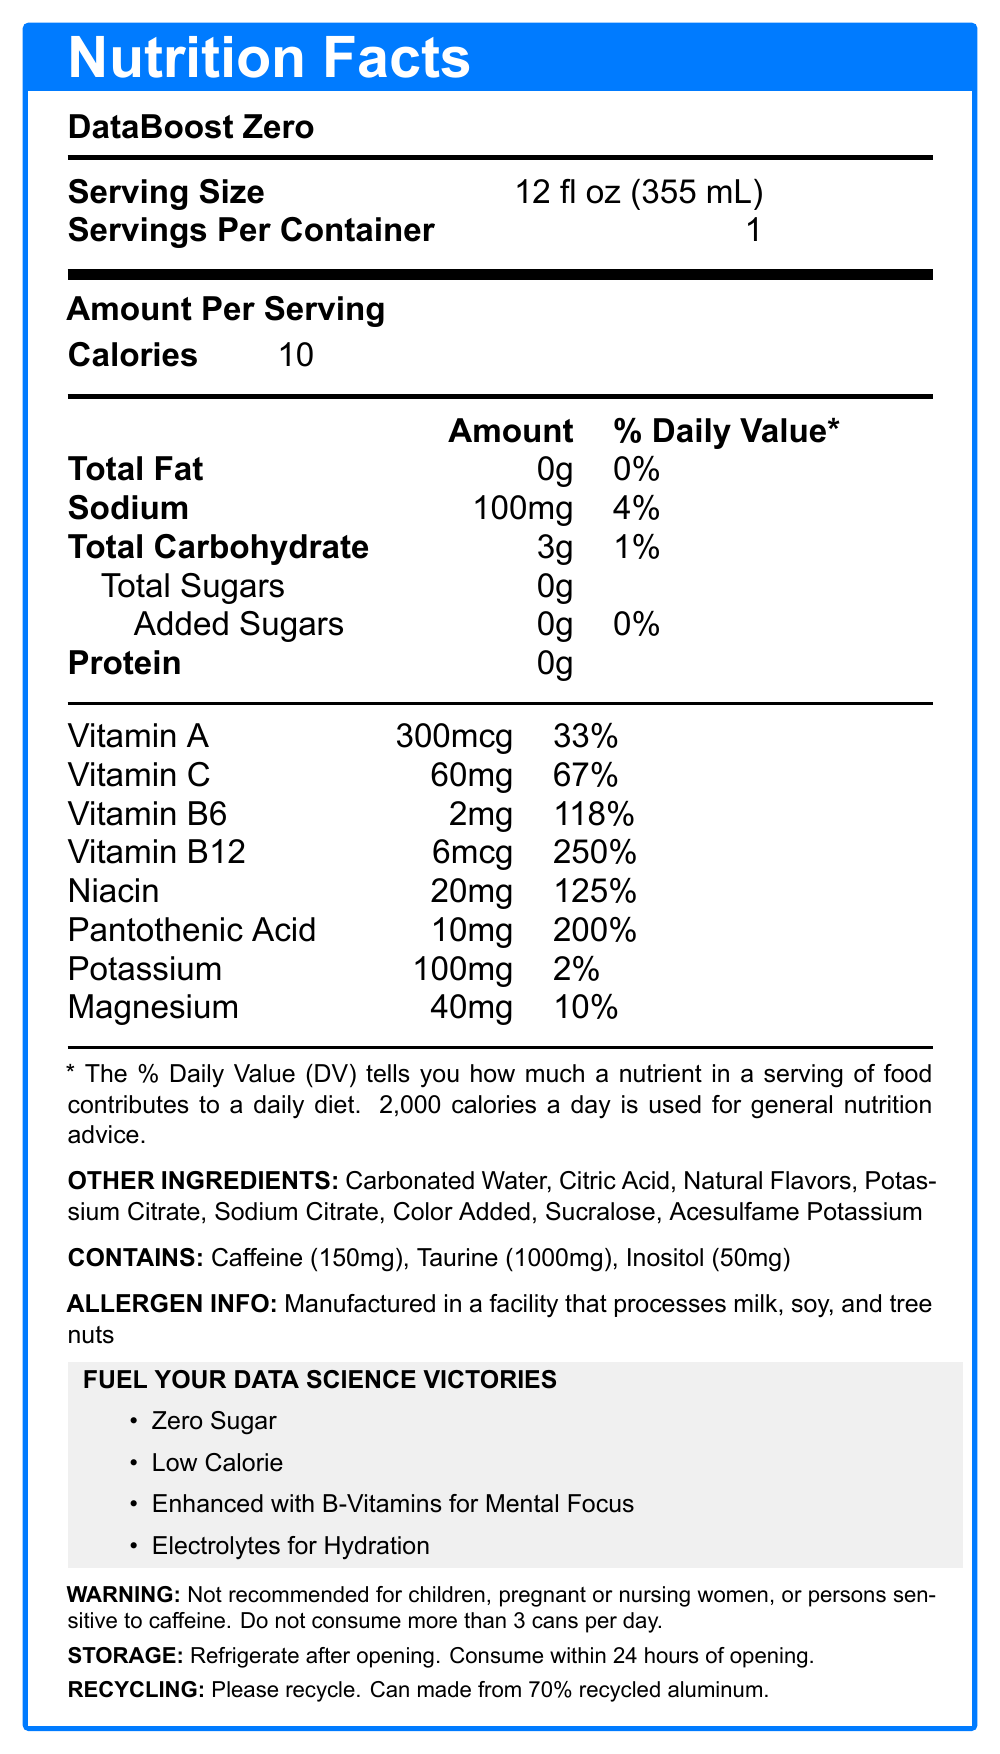what is the serving size of DataBoost Zero? The document specifies the serving size as 12 fl oz (355 mL) under the section "Serving Size".
Answer: 12 fl oz (355 mL) how many calories are there per serving? The document states that the amount per serving is 10 calories.
Answer: 10 calories what percentage of the daily value of sodium does one serving contain? The document lists 100mg of sodium per serving, which is 4% of the daily value.
Answer: 4% what vitamins are included in DataBoost Zero? The document lists these vitamins along with their amounts and daily values.
Answer: Vitamin A, Vitamin C, Vitamin B6, Vitamin B12, Niacin, Pantothenic Acid what is the main marketing tagline for DataBoost Zero? The document highlights the tagline “Fuel Your Data Science Victories”.
Answer: Fuel Your Data Science Victories what is the total carbohydrate content in a single serving? The document shows that the total carbohydrate amount per serving is 3g.
Answer: 3g which of the following is an artificial sweetener found in DataBoost Zero? A. Aspartame B. Sucralose C. Saccharin The document lists Sucralose and Acesulfame Potassium as the artificial sweeteners in DataBoost Zero.
Answer: B. Sucralose what is the daily value percentage of Pantothenic Acid in DataBoost Zero? A. 125% B. 200% C. 250% D. 33% The document specifies that the daily value percentage of Pantothenic Acid is 200%.
Answer: B. 200% is DataBoost Zero recommended for children? The document includes a warning that it is not recommended for children, pregnant or nursing women, or persons sensitive to caffeine.
Answer: No does DataBoost Zero contain any protein? The document shows that the protein amount per serving is 0g.
Answer: No what benefits are claimed by using DataBoost Zero according to the document? The document lists these functional benefits in the section "functional benefits".
Answer: Improved Mental Focus, Enhanced Alertness, Increased Productivity summarize the main idea of the document. The document provides nutritional information, ingredient lists, and marketing statements aimed at a specific target audience, highlighting the product's benefits and usage recommendations.
Answer: DataBoost Zero is a low-calorie energy drink designed for software engineers and data scientists. It contains vitamins, electrolytes, and zero sugar, aiming to improve mental focus, alertness, and productivity. The product contains several beneficial nutrients but includes a warning for certain groups of people. how much caffeine is there in a can of DataBoost Zero? The document states that a can of DataBoost Zero contains 150mg of caffeine.
Answer: 150mg what is the total vitamin B12 content in DataBoost Zero? Can it be determined if this content exceeds the US daily recommended intake for adults? The document provides the amount of Vitamin B12 (6mcg) and the daily value percentage (250%), but without knowing the specific recommended intake for adults (which can vary based on sources and guidelines), it cannot be conclusively determined from the document alone.
Answer: Not enough information 